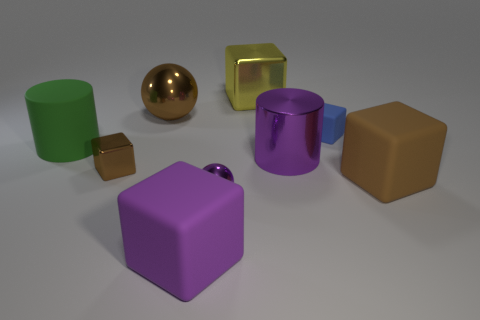Subtract all large yellow metal blocks. How many blocks are left? 4 Add 1 large yellow blocks. How many objects exist? 10 Subtract all purple cylinders. How many cylinders are left? 1 Subtract all spheres. How many objects are left? 7 Subtract 2 cylinders. How many cylinders are left? 0 Subtract all green cylinders. Subtract all red spheres. How many cylinders are left? 1 Subtract all purple cylinders. How many brown blocks are left? 2 Subtract all big brown rubber things. Subtract all big yellow metal things. How many objects are left? 7 Add 5 large purple cylinders. How many large purple cylinders are left? 6 Add 3 small metal objects. How many small metal objects exist? 5 